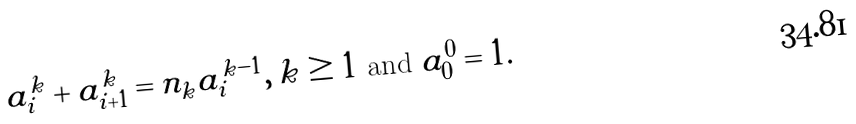<formula> <loc_0><loc_0><loc_500><loc_500>a _ { i } ^ { k } + a _ { i + 1 } ^ { k } = n _ { k } a _ { i } ^ { k - 1 } , \, k \geq 1 \text { and } a _ { 0 } ^ { 0 } = 1 .</formula> 